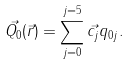<formula> <loc_0><loc_0><loc_500><loc_500>\vec { Q _ { 0 } } ( \vec { r } ) = \sum _ { j = 0 } ^ { j = 5 } \vec { c _ { j } } q _ { 0 j } .</formula> 